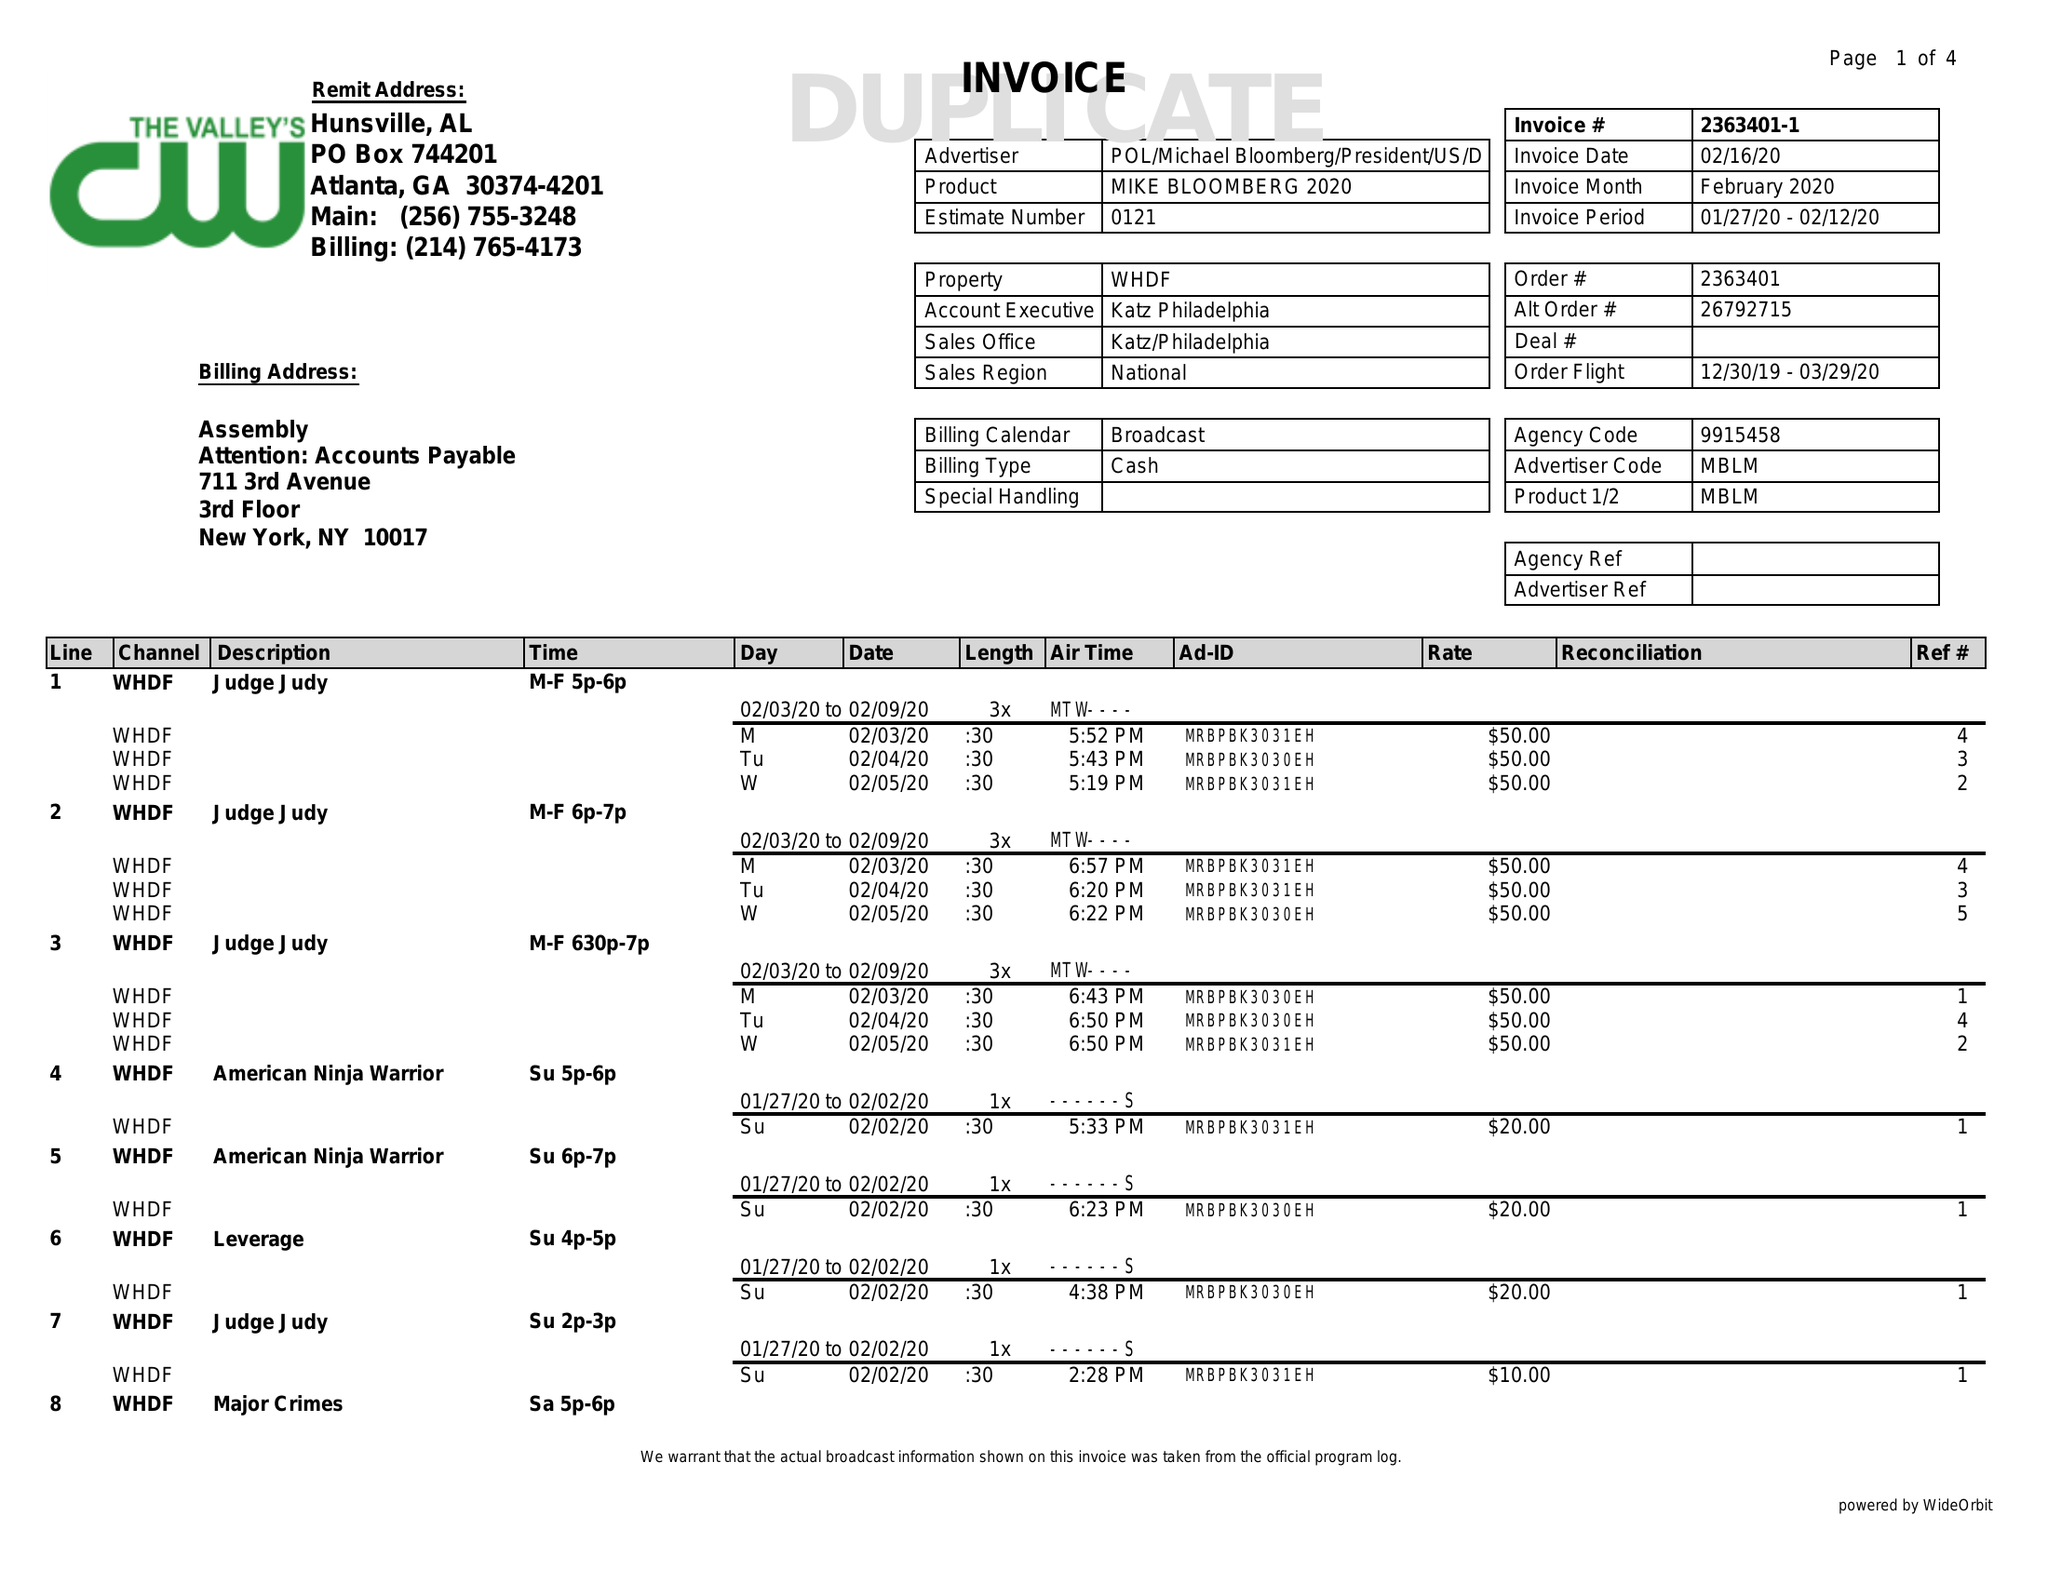What is the value for the gross_amount?
Answer the question using a single word or phrase. 2580.00 